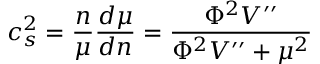Convert formula to latex. <formula><loc_0><loc_0><loc_500><loc_500>c _ { s } ^ { 2 } = \frac { n } { \mu } \frac { d \mu } { d n } = \frac { \Phi ^ { 2 } V ^ { \prime \prime } } { \Phi ^ { 2 } V ^ { \prime \prime } + \mu ^ { 2 } }</formula> 